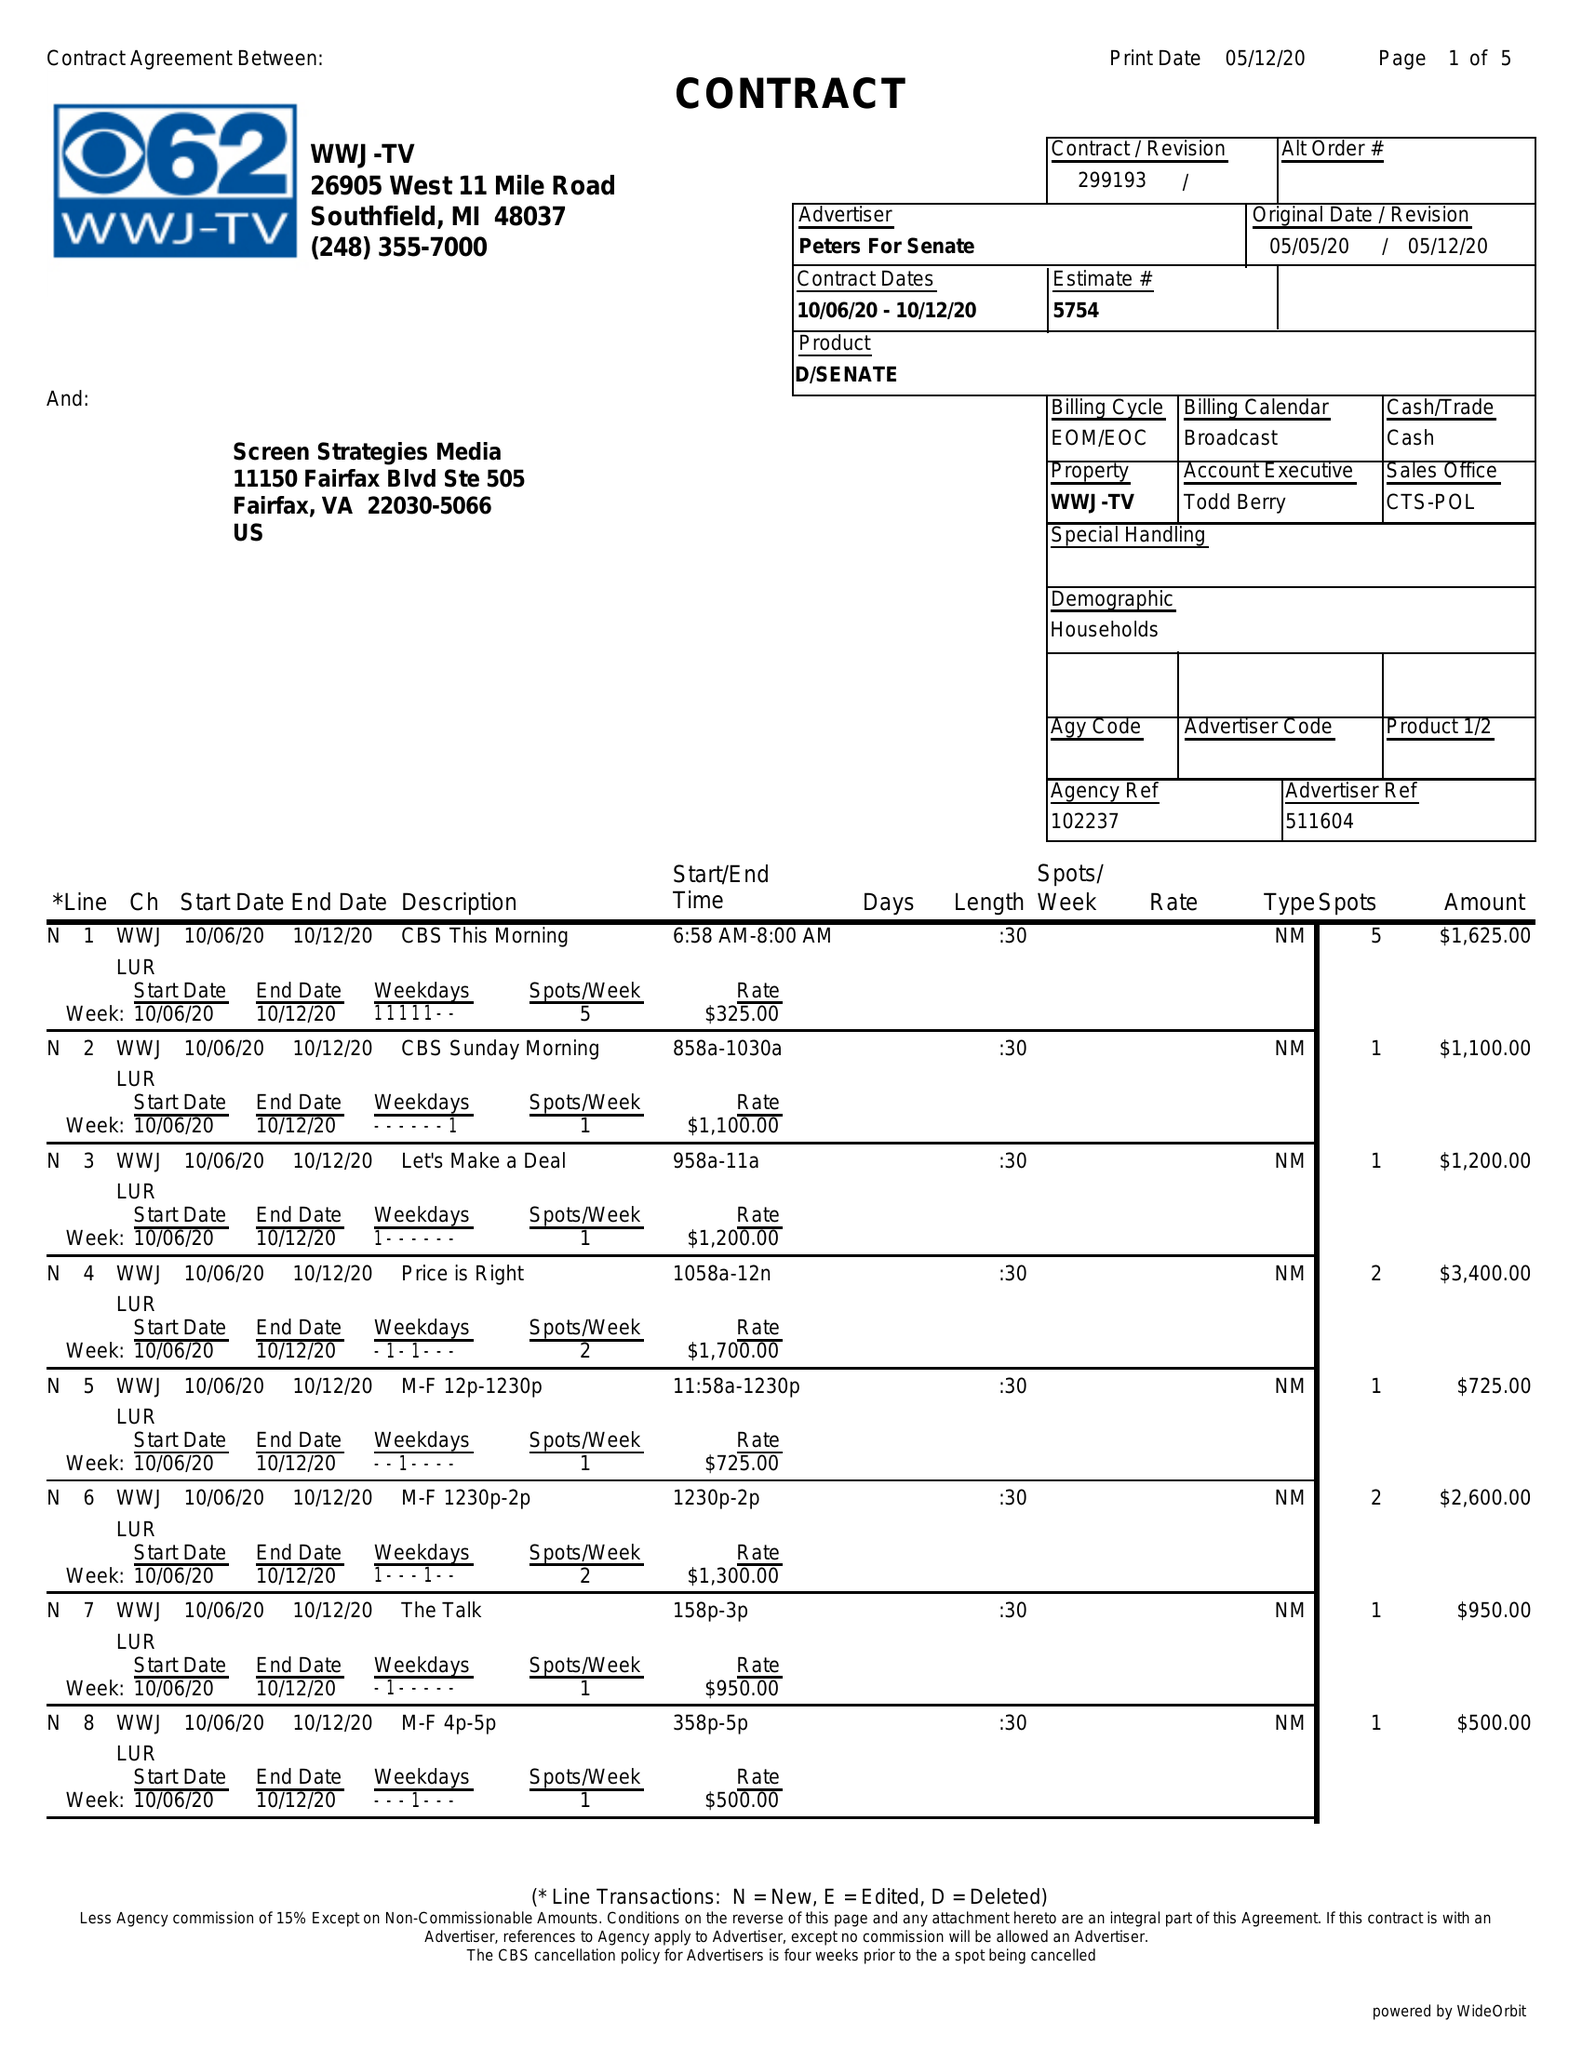What is the value for the flight_to?
Answer the question using a single word or phrase. 10/12/20 